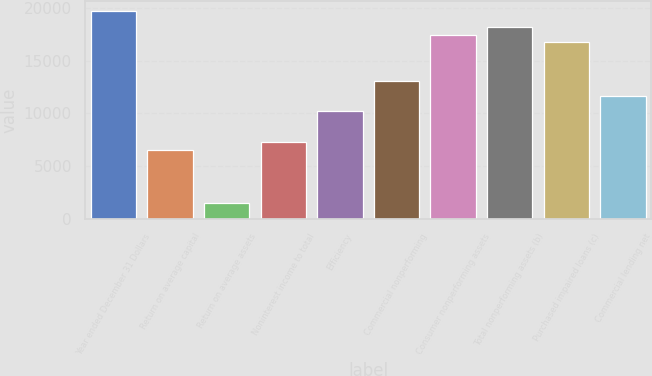<chart> <loc_0><loc_0><loc_500><loc_500><bar_chart><fcel>Year ended December 31 Dollars<fcel>Return on average capital<fcel>Return on average assets<fcel>Noninterest income to total<fcel>Efficiency<fcel>Commercial nonperforming<fcel>Consumer nonperforming assets<fcel>Total nonperforming assets (b)<fcel>Purchased impaired loans (c)<fcel>Commercial lending net<nl><fcel>19660.9<fcel>6553.86<fcel>1456.67<fcel>7282.03<fcel>10194.7<fcel>13107.4<fcel>17476.4<fcel>18204.6<fcel>16748.2<fcel>11651<nl></chart> 